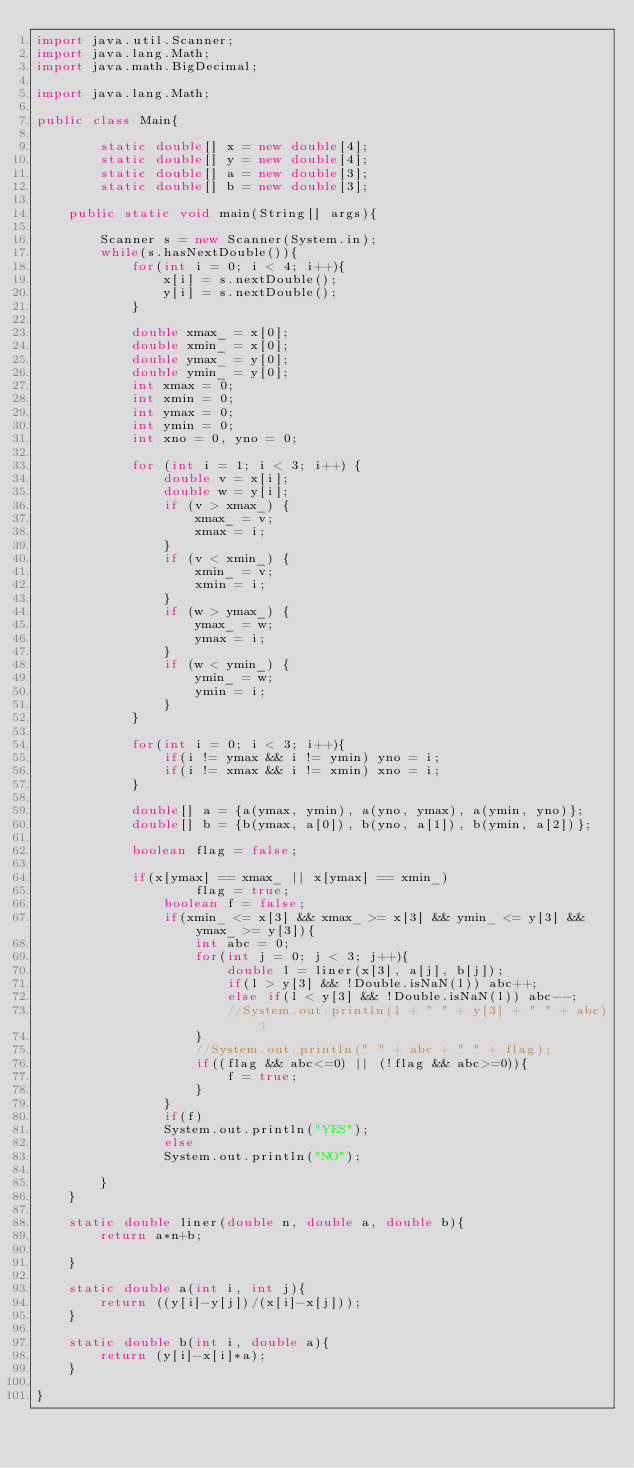<code> <loc_0><loc_0><loc_500><loc_500><_Java_>import java.util.Scanner;
import java.lang.Math;
import java.math.BigDecimal;

import java.lang.Math;

public class Main{
	
		static double[] x = new double[4];
		static double[] y = new double[4];
		static double[] a = new double[3];
		static double[] b = new double[3];
		
	public static void main(String[] args){

		Scanner s = new Scanner(System.in);
		while(s.hasNextDouble()){
			for(int i = 0; i < 4; i++){
				x[i] = s.nextDouble();
				y[i] = s.nextDouble();
			}
			
			double xmax_ = x[0];
			double xmin_ = x[0];
			double ymax_ = y[0];
			double ymin_ = y[0];
			int xmax = 0;
			int xmin = 0;
			int ymax = 0;
			int ymin = 0;
			int xno = 0, yno = 0;
			
			for (int i = 1; i < 3; i++) {
			    double v = x[i];
			    double w = y[i];
			    if (v > xmax_) {
			        xmax_ = v;
					xmax = i;
			    }
			    if (v < xmin_) {
			        xmin_ = v;
					xmin = i;
			    }
			    if (w > ymax_) {
			        ymax_ = w;
					ymax = i;
			    }
			    if (w < ymin_) {
			        ymin_ = w;
					ymin = i;
			    }
			}
	
			for(int i = 0; i < 3; i++){
				if(i != ymax && i != ymin) yno = i;
				if(i != xmax && i != xmin) xno = i;
			}
			
			double[] a = {a(ymax, ymin), a(yno, ymax), a(ymin, yno)};
			double[] b = {b(ymax, a[0]), b(yno, a[1]), b(ymin, a[2])};
			
			boolean flag = false;
			
			if(x[ymax] == xmax_ || x[ymax] == xmin_)
					flag = true;
				boolean f = false;
				if(xmin_ <= x[3] && xmax_ >= x[3] && ymin_ <= y[3] && ymax_ >= y[3]){
					int abc = 0;
					for(int j = 0; j < 3; j++){
						double l = liner(x[3], a[j], b[j]);
						if(l > y[3] && !Double.isNaN(l)) abc++;
						else if(l < y[3] && !Double.isNaN(l)) abc--;
						//System.out.println(l + " " + y[3] + " " + abc);
					}
					//System.out.println(" " + abc + " " + flag);
					if((flag && abc<=0) || (!flag && abc>=0)){
						f = true;
					}
				}
				if(f)
				System.out.println("YES");
				else
				System.out.println("NO");
				
		}
	}
	
	static double liner(double n, double a, double b){
		return a*n+b;
		
	}
	
	static double a(int i, int j){
		return ((y[i]-y[j])/(x[i]-x[j]));
	}
	
	static double b(int i, double a){
		return (y[i]-x[i]*a);
	}
	
}
</code> 